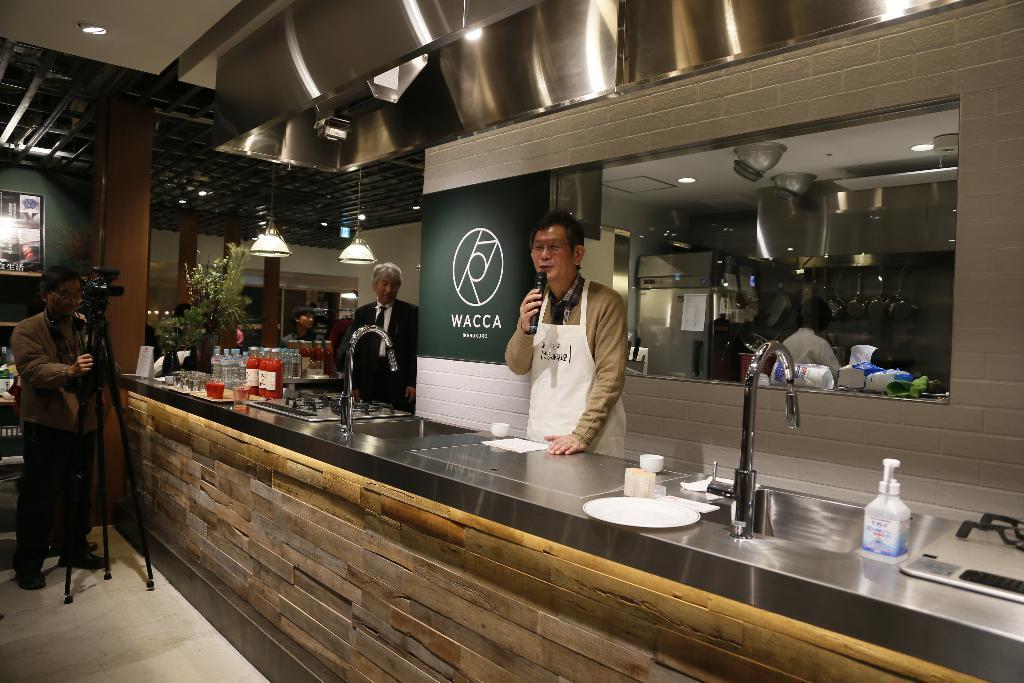Can you describe this image briefly? In this picture I can see some people are standing. This person is holding a microphone and wearing an apron. This person holding a video camera. On the kitchen top I can see sinks which has taps on it, bottles, plates and other objects on it. In the background I can see lights, kitchen, a refrigerator, lights on the ceiling and other objects over here. 